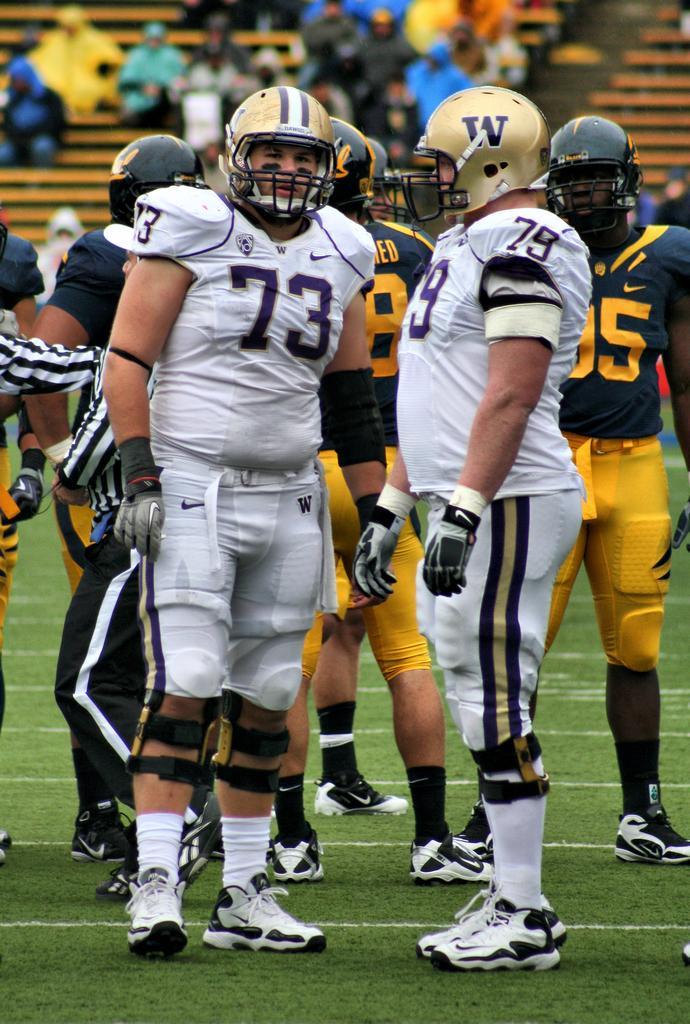In one or two sentences, can you explain what this image depicts? In this image I can see few persons wearing sports dress and standing on the ground. There is some grass on the ground. In the background I can see few persons sitting on the chairs. 